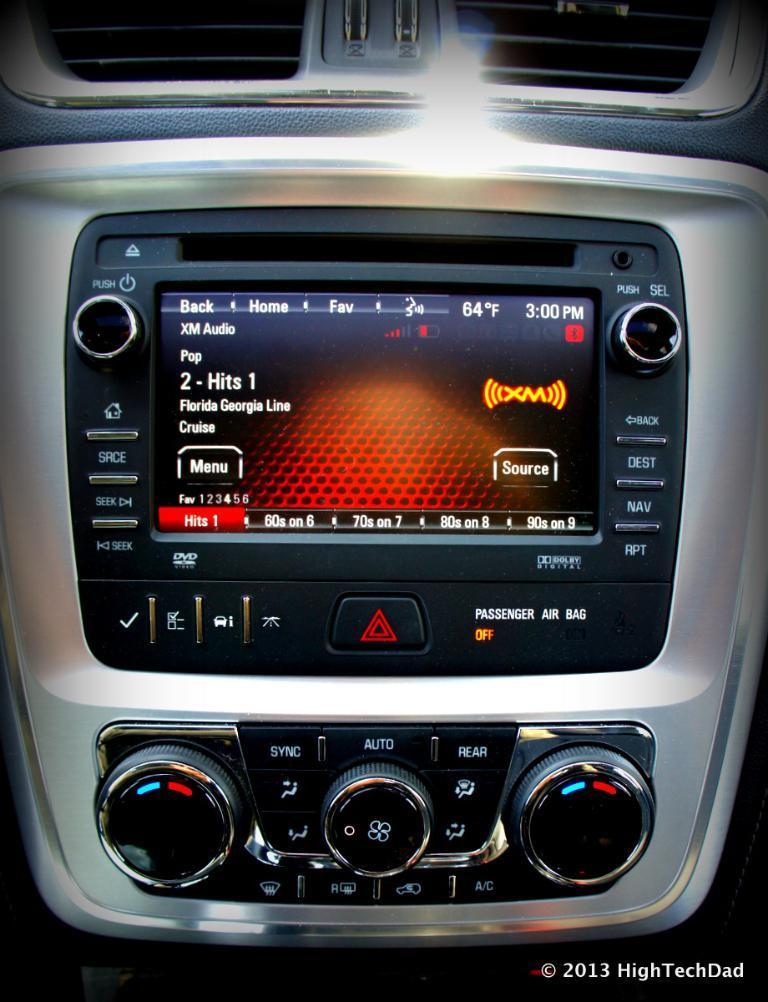Describe this image in one or two sentences. In this image we can see the car stereo music system and this is a watermark. 